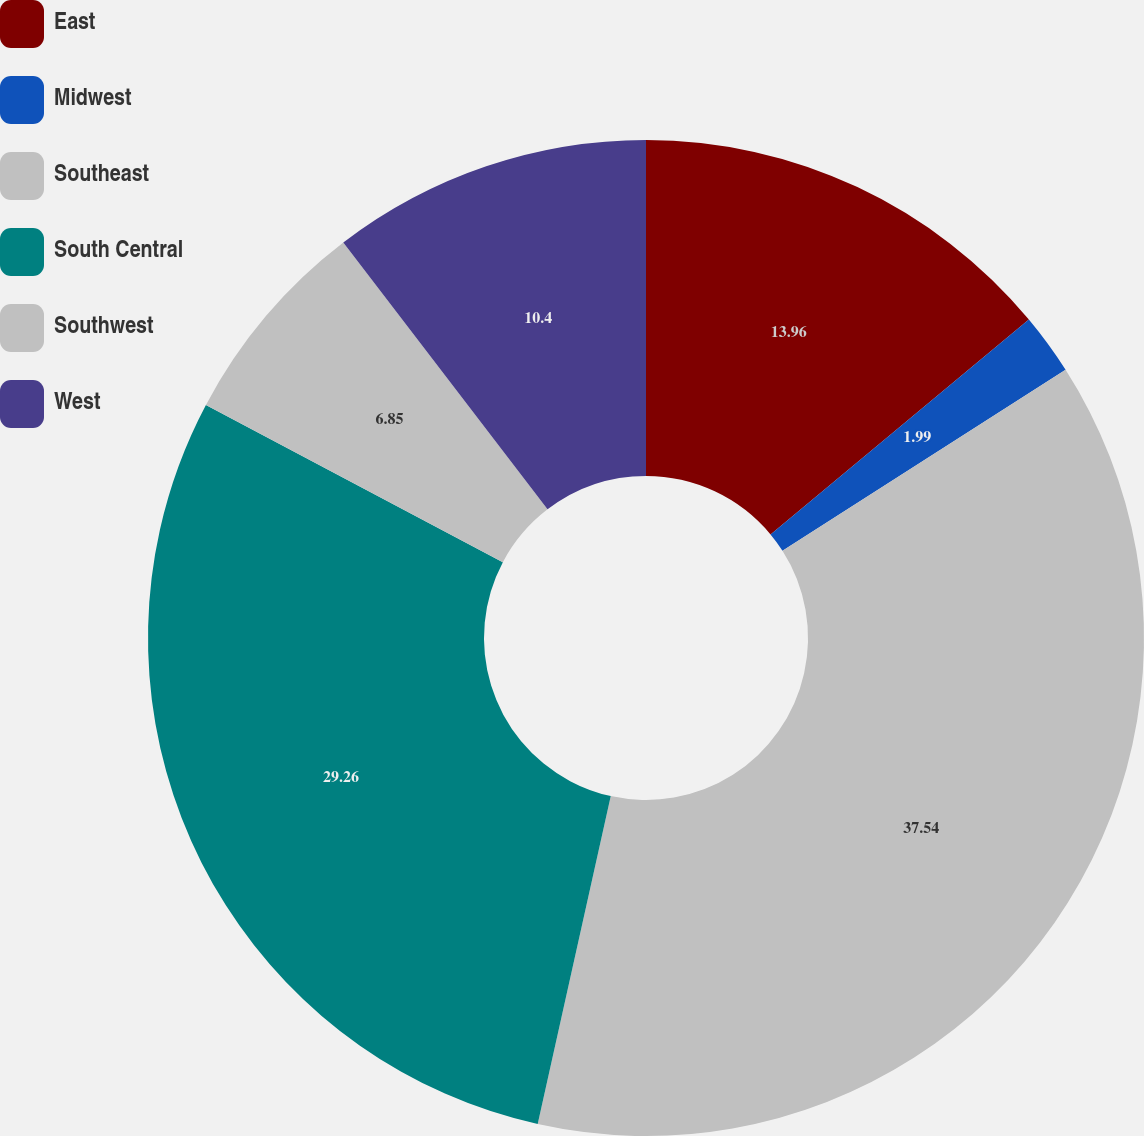Convert chart. <chart><loc_0><loc_0><loc_500><loc_500><pie_chart><fcel>East<fcel>Midwest<fcel>Southeast<fcel>South Central<fcel>Southwest<fcel>West<nl><fcel>13.96%<fcel>1.99%<fcel>37.55%<fcel>29.27%<fcel>6.85%<fcel>10.4%<nl></chart> 